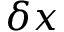<formula> <loc_0><loc_0><loc_500><loc_500>\delta x</formula> 